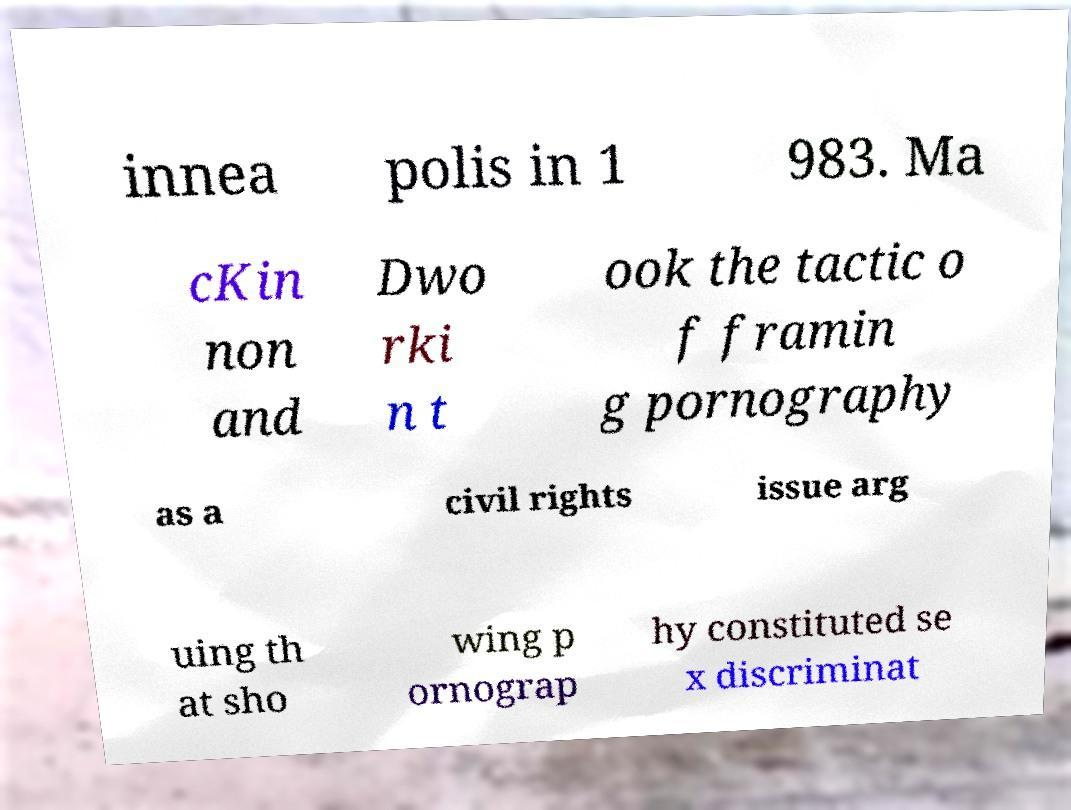For documentation purposes, I need the text within this image transcribed. Could you provide that? innea polis in 1 983. Ma cKin non and Dwo rki n t ook the tactic o f framin g pornography as a civil rights issue arg uing th at sho wing p ornograp hy constituted se x discriminat 